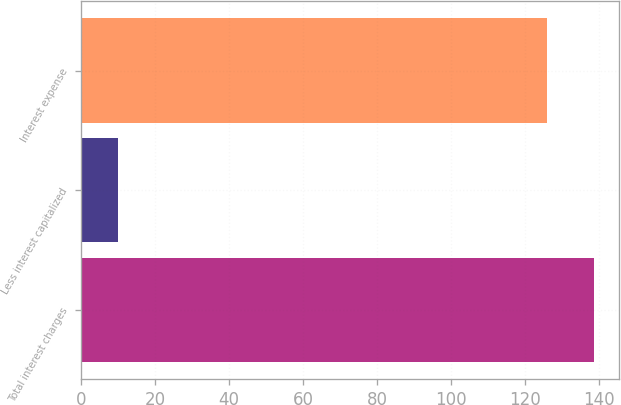<chart> <loc_0><loc_0><loc_500><loc_500><bar_chart><fcel>Total interest charges<fcel>Less interest capitalized<fcel>Interest expense<nl><fcel>138.6<fcel>10<fcel>126<nl></chart> 